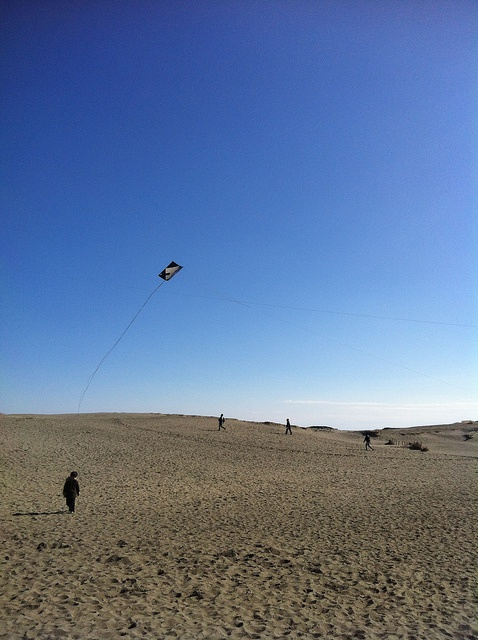Describe the objects in this image and their specific colors. I can see people in navy, black, and gray tones, kite in navy, black, gray, and darkgray tones, people in navy, black, gray, and darkgray tones, people in navy, black, and gray tones, and people in navy, black, gray, and darkgray tones in this image. 